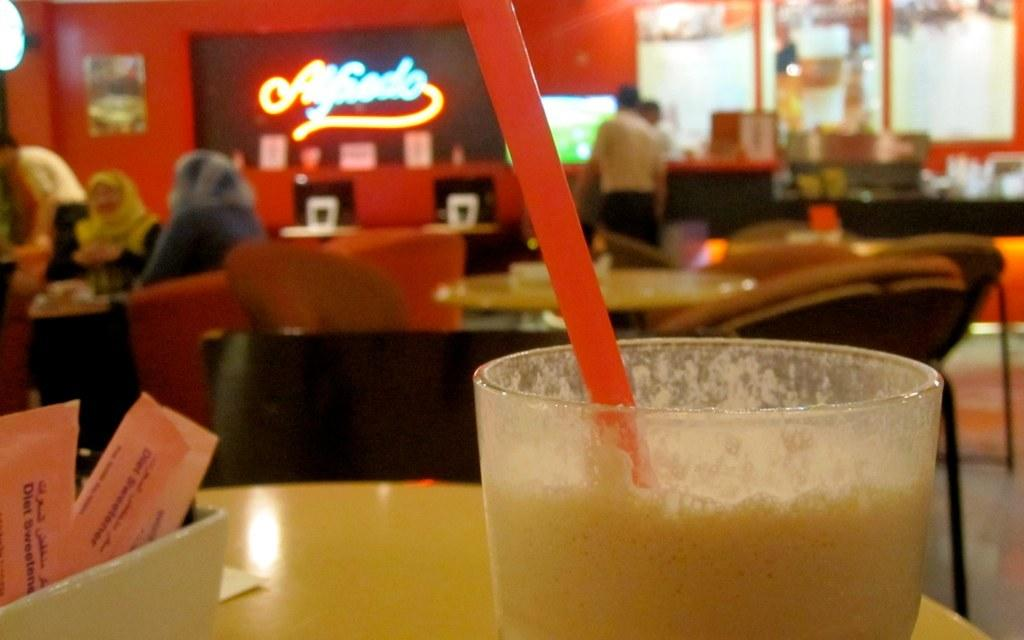What is on the table in the image? There is a glass on a table in the image. What is inside the glass? There is a straw in the glass. What other furniture can be seen in the image? There are more tables and chairs visible in the image. What is happening on the left side of the image? People are sitting at the left side of the image. How many snails are crawling on the table in the image? There are no snails visible in the image; it only shows a glass with a straw on a table. 